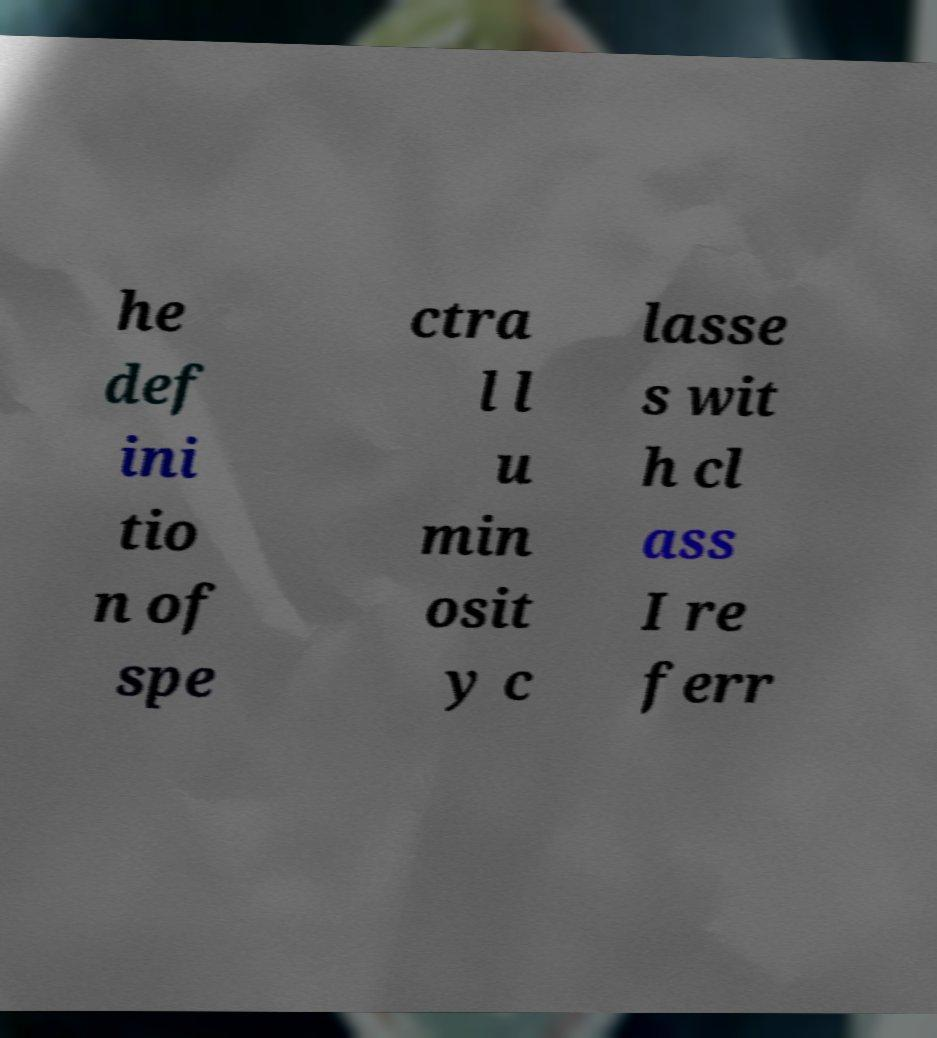There's text embedded in this image that I need extracted. Can you transcribe it verbatim? he def ini tio n of spe ctra l l u min osit y c lasse s wit h cl ass I re ferr 